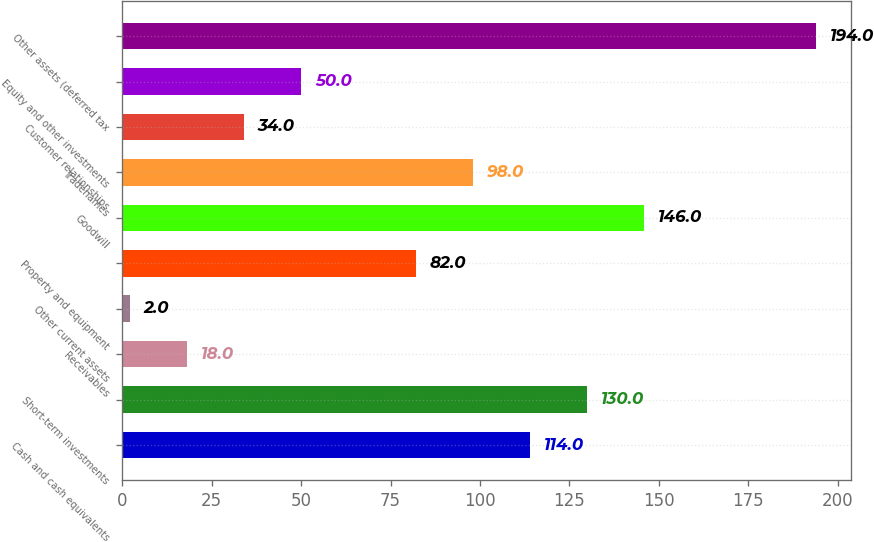Convert chart. <chart><loc_0><loc_0><loc_500><loc_500><bar_chart><fcel>Cash and cash equivalents<fcel>Short-term investments<fcel>Receivables<fcel>Other current assets<fcel>Property and equipment<fcel>Goodwill<fcel>Tradenames<fcel>Customer relationships<fcel>Equity and other investments<fcel>Other assets (deferred tax<nl><fcel>114<fcel>130<fcel>18<fcel>2<fcel>82<fcel>146<fcel>98<fcel>34<fcel>50<fcel>194<nl></chart> 